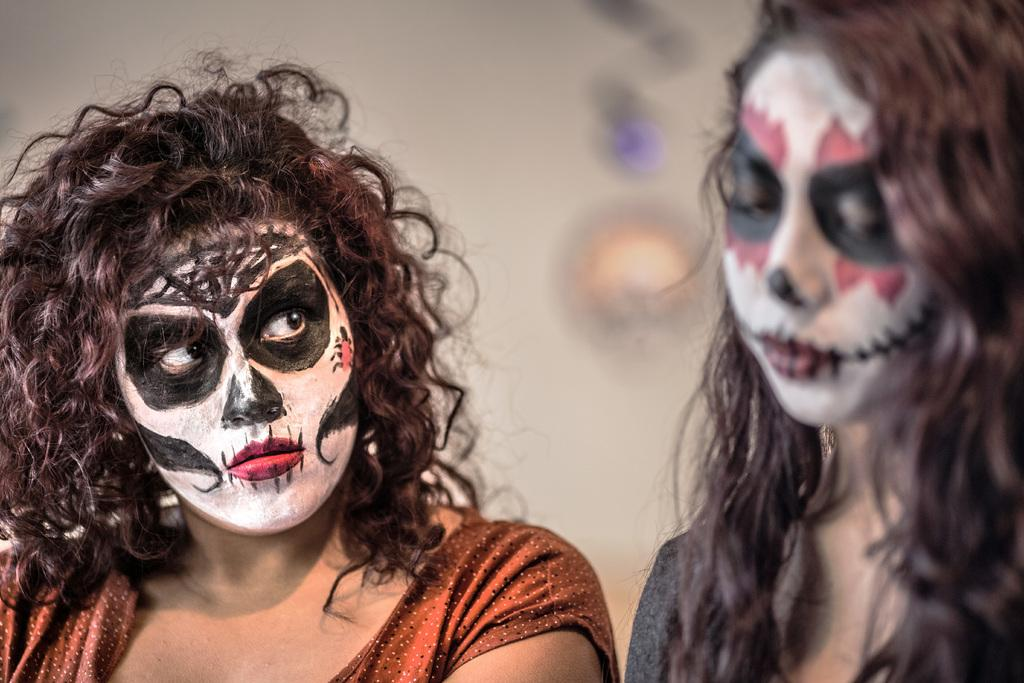How many people are in the image? There are two women in the image. What can be observed on the women's faces? The women have different costumes on their faces. What is visible in the background of the image? There is a wall in the background of the image. Can you describe any objects on the wall? There is a light on the wall. What type of bone can be seen in the image? There is no bone present in the image. What are the women reading in the image? The image does not show the women reading anything. 